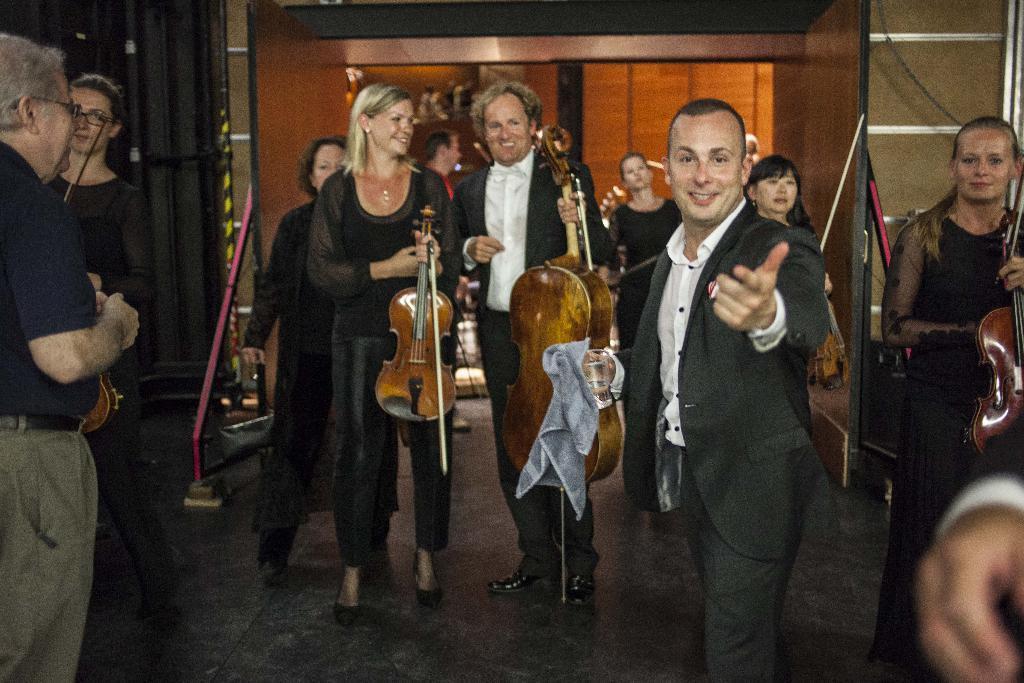In one or two sentences, can you explain what this image depicts? In this image I see number of people who are on the path, in which few of them are holding the musical instruments and few of them are smiling. 